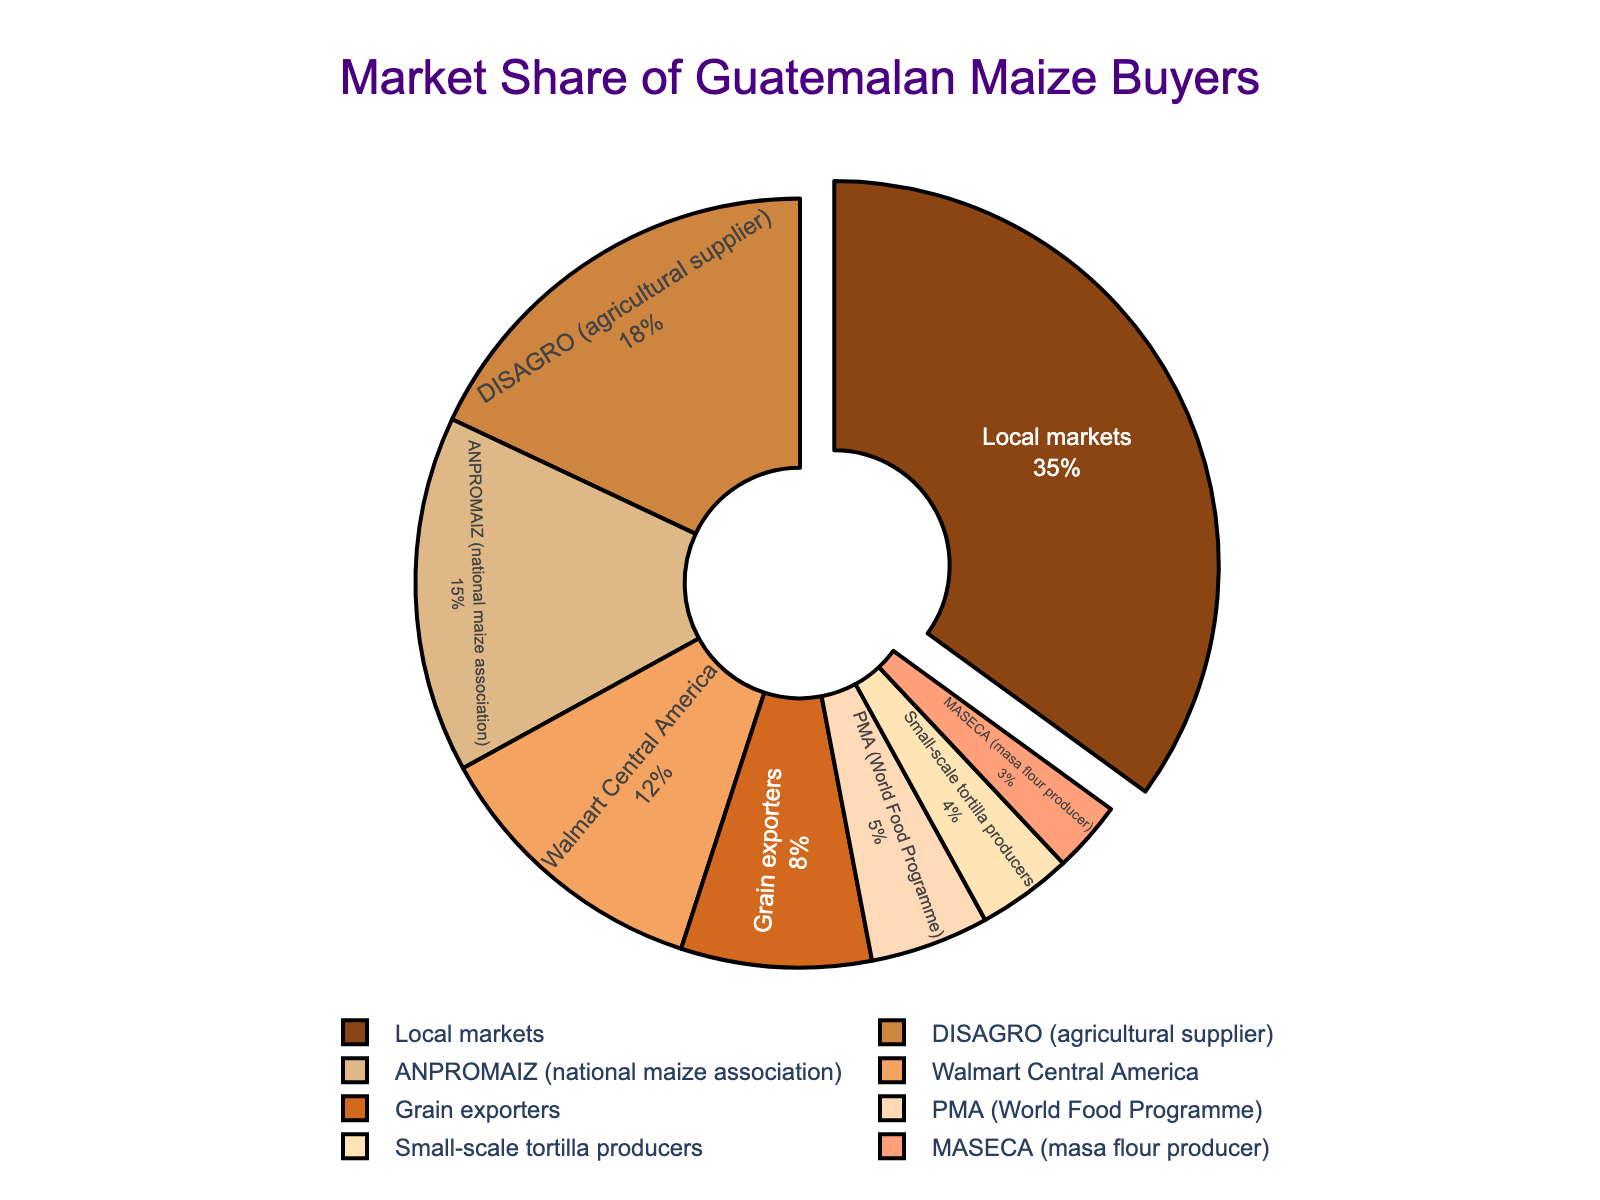Which buyer has the largest market share for Guatemalan maize? By looking at the size of the segments, the "Local markets" section is the largest. The pie chart specifically pulls this segment out to highlight it.
Answer: Local markets What is the combined market share of DISAGRO and ANPROMAIZ? The percentages for DISAGRO and ANPROMAIZ are 18% and 15% respectively. Summing these gives 18 + 15 = 33%.
Answer: 33% Which three buyers have the smallest market shares? The smallest segments, in descending order, are MASECA, Small-scale tortilla producers, and PMA with 3%, 4%, and 5% respectively.
Answer: MASECA, Small-scale tortilla producers, PMA Is Walmart Central America's market share larger or smaller than that of ANPROMAIZ? By comparing the two percentages, Walmart Central America has 12% while ANPROMAIZ has 15%. Therefore, Walmart Central America's share is smaller.
Answer: Smaller How much larger is the market share of Local markets compared to Grain exporters? Local markets have 35% and Grain exporters have 8%. Subtracting these gives 35 - 8 = 27%.
Answer: 27% What is the total market share of buyers with less than 10% share each? Adding the shares of buyers with less than 10%: Grain exporters (8%) + PMA (5%) + Small-scale tortilla producers (4%) + MASECA (3%) sums to 8 + 5 + 4 + 3 = 20%.
Answer: 20% What is the difference in market share between the two largest buyers? The two largest buyers are Local markets with 35% and DISAGRO with 18%. The difference is 35 - 18 = 17%.
Answer: 17% How many buyers have a market share greater than 10%? The buyers with more than 10% share are Local markets (35%), DISAGRO (18%), ANPROMAIZ (15%), and Walmart Central America (12%). Counting these gives 4 buyers.
Answer: 4 If ANPROMAIZ's market share increased by 5%, what would be its new percentage? ANPROMAIZ currently has a 15% share. Adding 5% gives 15 + 5 = 20%.
Answer: 20% Which buyer's market segment is visually highlighted in the pie chart, and why? The Local markets segment is visually highlighted and slightly pulled out from the pie chart. This emphasizes it as the buyer with the largest market share.
Answer: Local markets 